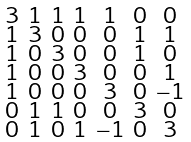Convert formula to latex. <formula><loc_0><loc_0><loc_500><loc_500>\begin{smallmatrix} 3 & 1 & 1 & 1 & 1 & 0 & 0 \\ 1 & 3 & 0 & 0 & 0 & 1 & 1 \\ 1 & 0 & 3 & 0 & 0 & 1 & 0 \\ 1 & 0 & 0 & 3 & 0 & 0 & 1 \\ 1 & 0 & 0 & 0 & 3 & 0 & - 1 \\ 0 & 1 & 1 & 0 & 0 & 3 & 0 \\ 0 & 1 & 0 & 1 & - 1 & 0 & 3 \end{smallmatrix}</formula> 